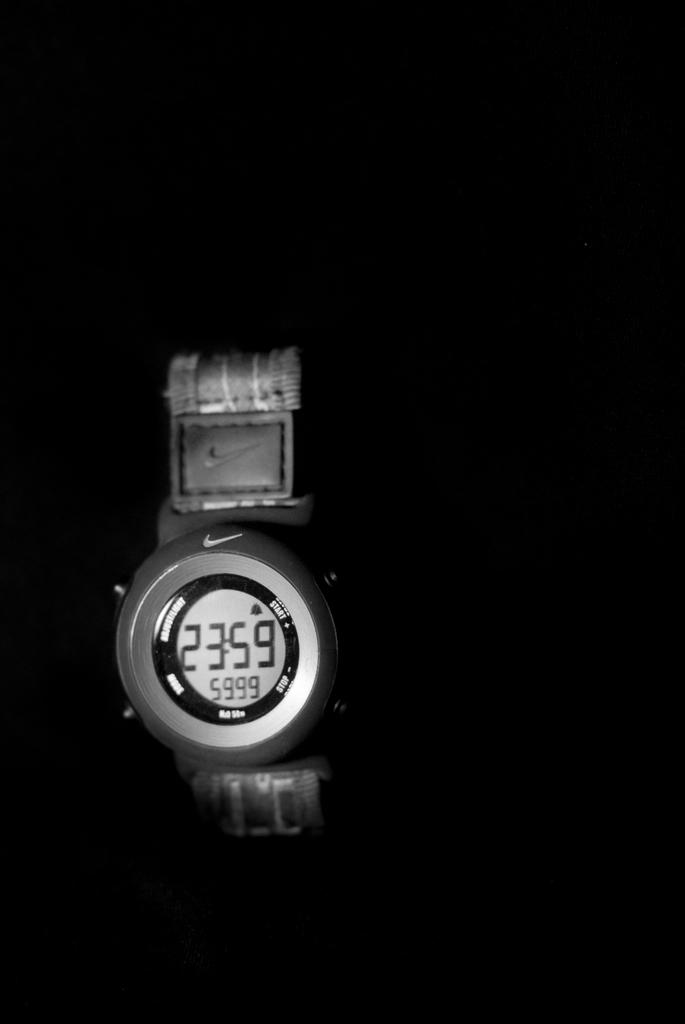<image>
Create a compact narrative representing the image presented. A Nike brand watch shows that the current time is 23:59. 